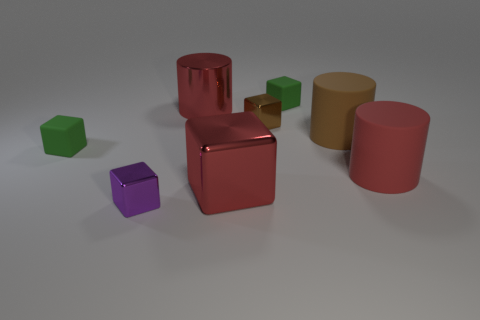The object that is both left of the metallic cylinder and behind the purple block has what shape?
Offer a very short reply. Cube. What is the color of the shiny thing that is the same size as the brown metal block?
Your answer should be compact. Purple. Are there any large shiny things that have the same color as the large block?
Provide a succinct answer. Yes. Does the metal block that is left of the red metallic cylinder have the same size as the red metal object in front of the big red matte thing?
Your answer should be compact. No. There is a large red object that is both on the left side of the red matte cylinder and behind the large block; what material is it?
Give a very brief answer. Metal. There is a rubber cylinder that is the same color as the large metal cube; what is its size?
Offer a terse response. Large. What number of other things are the same size as the metal cylinder?
Your response must be concise. 3. There is a thing that is left of the small purple metal thing; what is its material?
Your answer should be very brief. Rubber. Do the brown rubber object and the small brown shiny thing have the same shape?
Provide a short and direct response. No. How many other objects are the same shape as the large red rubber thing?
Provide a succinct answer. 2. 